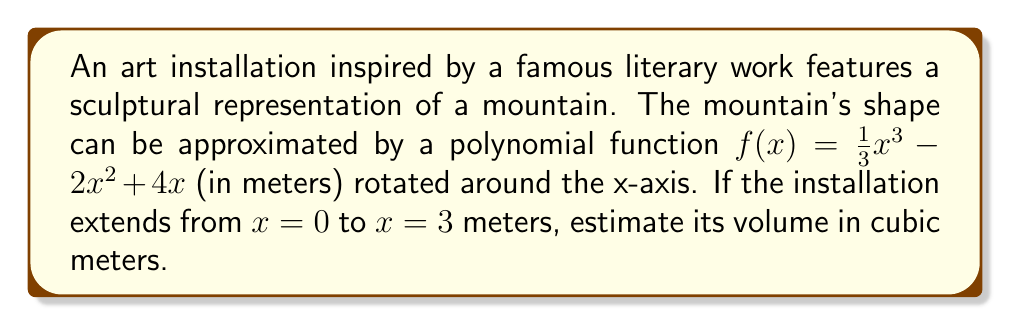Solve this math problem. To estimate the volume of this three-dimensional art installation, we need to use the volume formula for a solid of revolution:

$$V = \pi \int_{a}^{b} [f(x)]^2 dx$$

Where $f(x)$ is the function being rotated, and $[a,b]$ is the interval.

Step 1: Identify the function and interval
$f(x) = \frac{1}{3}x^3 - 2x^2 + 4x$
$a = 0$, $b = 3$

Step 2: Square the function
$[f(x)]^2 = (\frac{1}{3}x^3 - 2x^2 + 4x)^2$
$= \frac{1}{9}x^6 - \frac{4}{3}x^5 + \frac{8}{3}x^4 + 4x^4 - 16x^3 + 16x^2$
$= \frac{1}{9}x^6 - \frac{4}{3}x^5 + \frac{20}{3}x^4 - 16x^3 + 16x^2$

Step 3: Integrate the squared function
$$\int_{0}^{3} (\frac{1}{9}x^6 - \frac{4}{3}x^5 + \frac{20}{3}x^4 - 16x^3 + 16x^2) dx$$
$$= [\frac{1}{63}x^7 - \frac{2}{9}x^6 + \frac{5}{3}x^5 - 4x^4 + \frac{16}{3}x^3]_{0}^{3}$$

Step 4: Evaluate the integral
$$= (\frac{1}{63}(3^7) - \frac{2}{9}(3^6) + \frac{5}{3}(3^5) - 4(3^4) + \frac{16}{3}(3^3)) - (0)$$
$$= \frac{2187}{63} - 162 + 405 - 324 + 144 = 34.714285714 + 243 + 144 = 421.714285714$$

Step 5: Multiply by π
$V = \pi * 421.714285714 \approx 1324.90$ cubic meters
Answer: $1324.90$ m³ 